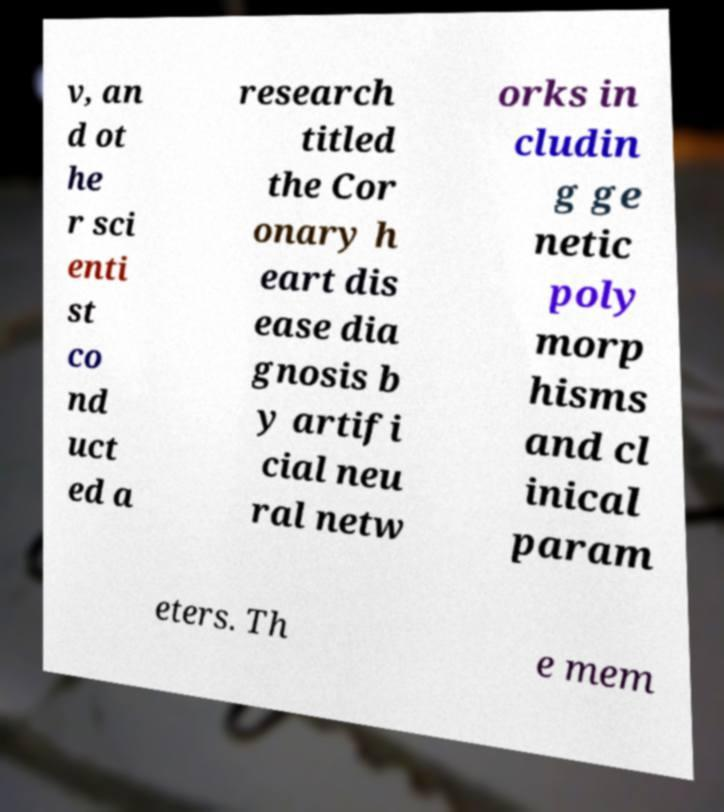Can you accurately transcribe the text from the provided image for me? v, an d ot he r sci enti st co nd uct ed a research titled the Cor onary h eart dis ease dia gnosis b y artifi cial neu ral netw orks in cludin g ge netic poly morp hisms and cl inical param eters. Th e mem 